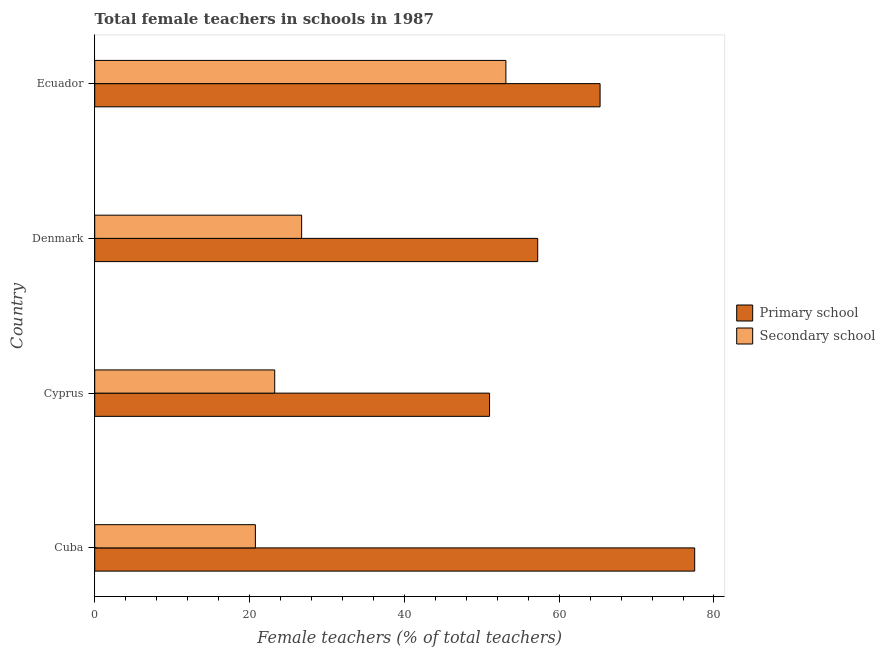How many different coloured bars are there?
Your response must be concise. 2. How many groups of bars are there?
Your answer should be compact. 4. Are the number of bars per tick equal to the number of legend labels?
Offer a very short reply. Yes. How many bars are there on the 1st tick from the top?
Ensure brevity in your answer.  2. How many bars are there on the 1st tick from the bottom?
Ensure brevity in your answer.  2. What is the label of the 2nd group of bars from the top?
Give a very brief answer. Denmark. In how many cases, is the number of bars for a given country not equal to the number of legend labels?
Keep it short and to the point. 0. What is the percentage of female teachers in secondary schools in Ecuador?
Your response must be concise. 53.12. Across all countries, what is the maximum percentage of female teachers in secondary schools?
Make the answer very short. 53.12. Across all countries, what is the minimum percentage of female teachers in primary schools?
Offer a very short reply. 51.01. In which country was the percentage of female teachers in primary schools maximum?
Provide a succinct answer. Cuba. In which country was the percentage of female teachers in secondary schools minimum?
Your answer should be compact. Cuba. What is the total percentage of female teachers in primary schools in the graph?
Your response must be concise. 251.03. What is the difference between the percentage of female teachers in secondary schools in Cyprus and that in Ecuador?
Your answer should be compact. -29.87. What is the difference between the percentage of female teachers in primary schools in Cyprus and the percentage of female teachers in secondary schools in Denmark?
Offer a very short reply. 24.28. What is the average percentage of female teachers in secondary schools per country?
Give a very brief answer. 30.96. What is the difference between the percentage of female teachers in secondary schools and percentage of female teachers in primary schools in Denmark?
Give a very brief answer. -30.5. What is the ratio of the percentage of female teachers in secondary schools in Cuba to that in Denmark?
Ensure brevity in your answer.  0.78. Is the percentage of female teachers in secondary schools in Cuba less than that in Cyprus?
Your answer should be very brief. Yes. Is the difference between the percentage of female teachers in primary schools in Cuba and Cyprus greater than the difference between the percentage of female teachers in secondary schools in Cuba and Cyprus?
Your answer should be very brief. Yes. What is the difference between the highest and the second highest percentage of female teachers in secondary schools?
Your response must be concise. 26.39. What is the difference between the highest and the lowest percentage of female teachers in secondary schools?
Offer a terse response. 32.36. In how many countries, is the percentage of female teachers in secondary schools greater than the average percentage of female teachers in secondary schools taken over all countries?
Your answer should be compact. 1. What does the 1st bar from the top in Denmark represents?
Keep it short and to the point. Secondary school. What does the 1st bar from the bottom in Cuba represents?
Ensure brevity in your answer.  Primary school. Are all the bars in the graph horizontal?
Ensure brevity in your answer.  Yes. How are the legend labels stacked?
Offer a very short reply. Vertical. What is the title of the graph?
Your answer should be very brief. Total female teachers in schools in 1987. What is the label or title of the X-axis?
Make the answer very short. Female teachers (% of total teachers). What is the label or title of the Y-axis?
Keep it short and to the point. Country. What is the Female teachers (% of total teachers) in Primary school in Cuba?
Your answer should be compact. 77.51. What is the Female teachers (% of total teachers) in Secondary school in Cuba?
Ensure brevity in your answer.  20.75. What is the Female teachers (% of total teachers) in Primary school in Cyprus?
Offer a terse response. 51.01. What is the Female teachers (% of total teachers) of Secondary school in Cyprus?
Make the answer very short. 23.25. What is the Female teachers (% of total teachers) of Primary school in Denmark?
Your response must be concise. 57.23. What is the Female teachers (% of total teachers) of Secondary school in Denmark?
Your answer should be very brief. 26.73. What is the Female teachers (% of total teachers) in Primary school in Ecuador?
Your answer should be very brief. 65.29. What is the Female teachers (% of total teachers) of Secondary school in Ecuador?
Your response must be concise. 53.12. Across all countries, what is the maximum Female teachers (% of total teachers) in Primary school?
Give a very brief answer. 77.51. Across all countries, what is the maximum Female teachers (% of total teachers) in Secondary school?
Ensure brevity in your answer.  53.12. Across all countries, what is the minimum Female teachers (% of total teachers) of Primary school?
Ensure brevity in your answer.  51.01. Across all countries, what is the minimum Female teachers (% of total teachers) of Secondary school?
Offer a very short reply. 20.75. What is the total Female teachers (% of total teachers) in Primary school in the graph?
Provide a succinct answer. 251.03. What is the total Female teachers (% of total teachers) of Secondary school in the graph?
Offer a terse response. 123.86. What is the difference between the Female teachers (% of total teachers) in Primary school in Cuba and that in Cyprus?
Offer a terse response. 26.5. What is the difference between the Female teachers (% of total teachers) of Secondary school in Cuba and that in Cyprus?
Give a very brief answer. -2.5. What is the difference between the Female teachers (% of total teachers) in Primary school in Cuba and that in Denmark?
Ensure brevity in your answer.  20.28. What is the difference between the Female teachers (% of total teachers) in Secondary school in Cuba and that in Denmark?
Your answer should be very brief. -5.98. What is the difference between the Female teachers (% of total teachers) of Primary school in Cuba and that in Ecuador?
Make the answer very short. 12.22. What is the difference between the Female teachers (% of total teachers) in Secondary school in Cuba and that in Ecuador?
Make the answer very short. -32.36. What is the difference between the Female teachers (% of total teachers) in Primary school in Cyprus and that in Denmark?
Offer a terse response. -6.22. What is the difference between the Female teachers (% of total teachers) of Secondary school in Cyprus and that in Denmark?
Your response must be concise. -3.48. What is the difference between the Female teachers (% of total teachers) of Primary school in Cyprus and that in Ecuador?
Your response must be concise. -14.28. What is the difference between the Female teachers (% of total teachers) in Secondary school in Cyprus and that in Ecuador?
Provide a succinct answer. -29.87. What is the difference between the Female teachers (% of total teachers) in Primary school in Denmark and that in Ecuador?
Provide a succinct answer. -8.06. What is the difference between the Female teachers (% of total teachers) of Secondary school in Denmark and that in Ecuador?
Ensure brevity in your answer.  -26.39. What is the difference between the Female teachers (% of total teachers) of Primary school in Cuba and the Female teachers (% of total teachers) of Secondary school in Cyprus?
Ensure brevity in your answer.  54.25. What is the difference between the Female teachers (% of total teachers) in Primary school in Cuba and the Female teachers (% of total teachers) in Secondary school in Denmark?
Ensure brevity in your answer.  50.78. What is the difference between the Female teachers (% of total teachers) in Primary school in Cuba and the Female teachers (% of total teachers) in Secondary school in Ecuador?
Your response must be concise. 24.39. What is the difference between the Female teachers (% of total teachers) in Primary school in Cyprus and the Female teachers (% of total teachers) in Secondary school in Denmark?
Your answer should be compact. 24.28. What is the difference between the Female teachers (% of total teachers) in Primary school in Cyprus and the Female teachers (% of total teachers) in Secondary school in Ecuador?
Your answer should be compact. -2.11. What is the difference between the Female teachers (% of total teachers) in Primary school in Denmark and the Female teachers (% of total teachers) in Secondary school in Ecuador?
Ensure brevity in your answer.  4.11. What is the average Female teachers (% of total teachers) of Primary school per country?
Provide a short and direct response. 62.76. What is the average Female teachers (% of total teachers) of Secondary school per country?
Ensure brevity in your answer.  30.96. What is the difference between the Female teachers (% of total teachers) in Primary school and Female teachers (% of total teachers) in Secondary school in Cuba?
Provide a short and direct response. 56.75. What is the difference between the Female teachers (% of total teachers) of Primary school and Female teachers (% of total teachers) of Secondary school in Cyprus?
Keep it short and to the point. 27.76. What is the difference between the Female teachers (% of total teachers) in Primary school and Female teachers (% of total teachers) in Secondary school in Denmark?
Give a very brief answer. 30.5. What is the difference between the Female teachers (% of total teachers) of Primary school and Female teachers (% of total teachers) of Secondary school in Ecuador?
Make the answer very short. 12.17. What is the ratio of the Female teachers (% of total teachers) in Primary school in Cuba to that in Cyprus?
Provide a succinct answer. 1.52. What is the ratio of the Female teachers (% of total teachers) of Secondary school in Cuba to that in Cyprus?
Provide a short and direct response. 0.89. What is the ratio of the Female teachers (% of total teachers) of Primary school in Cuba to that in Denmark?
Your answer should be very brief. 1.35. What is the ratio of the Female teachers (% of total teachers) of Secondary school in Cuba to that in Denmark?
Your response must be concise. 0.78. What is the ratio of the Female teachers (% of total teachers) in Primary school in Cuba to that in Ecuador?
Provide a succinct answer. 1.19. What is the ratio of the Female teachers (% of total teachers) in Secondary school in Cuba to that in Ecuador?
Give a very brief answer. 0.39. What is the ratio of the Female teachers (% of total teachers) of Primary school in Cyprus to that in Denmark?
Offer a very short reply. 0.89. What is the ratio of the Female teachers (% of total teachers) of Secondary school in Cyprus to that in Denmark?
Provide a short and direct response. 0.87. What is the ratio of the Female teachers (% of total teachers) of Primary school in Cyprus to that in Ecuador?
Your response must be concise. 0.78. What is the ratio of the Female teachers (% of total teachers) of Secondary school in Cyprus to that in Ecuador?
Your answer should be compact. 0.44. What is the ratio of the Female teachers (% of total teachers) of Primary school in Denmark to that in Ecuador?
Your answer should be compact. 0.88. What is the ratio of the Female teachers (% of total teachers) of Secondary school in Denmark to that in Ecuador?
Offer a very short reply. 0.5. What is the difference between the highest and the second highest Female teachers (% of total teachers) in Primary school?
Make the answer very short. 12.22. What is the difference between the highest and the second highest Female teachers (% of total teachers) of Secondary school?
Offer a very short reply. 26.39. What is the difference between the highest and the lowest Female teachers (% of total teachers) in Primary school?
Make the answer very short. 26.5. What is the difference between the highest and the lowest Female teachers (% of total teachers) of Secondary school?
Offer a terse response. 32.36. 